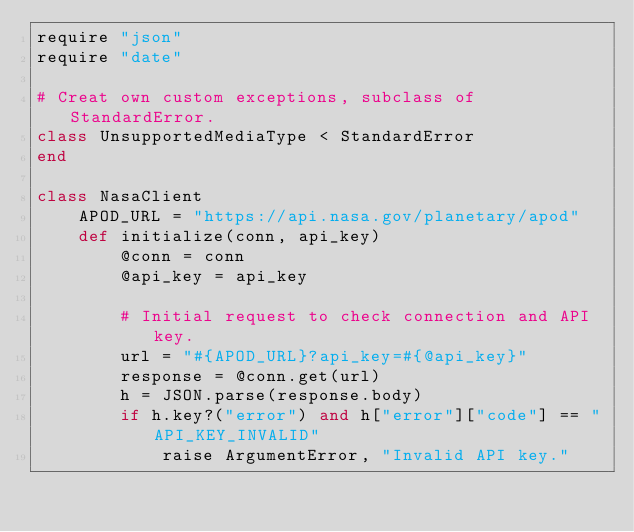Convert code to text. <code><loc_0><loc_0><loc_500><loc_500><_Ruby_>require "json"
require "date"

# Creat own custom exceptions, subclass of StandardError.
class UnsupportedMediaType < StandardError
end

class NasaClient
    APOD_URL = "https://api.nasa.gov/planetary/apod" 
    def initialize(conn, api_key)
        @conn = conn
        @api_key = api_key

        # Initial request to check connection and API key.
        url = "#{APOD_URL}?api_key=#{@api_key}"
        response = @conn.get(url)  
        h = JSON.parse(response.body)
        if h.key?("error") and h["error"]["code"] == "API_KEY_INVALID"
            raise ArgumentError, "Invalid API key."</code> 